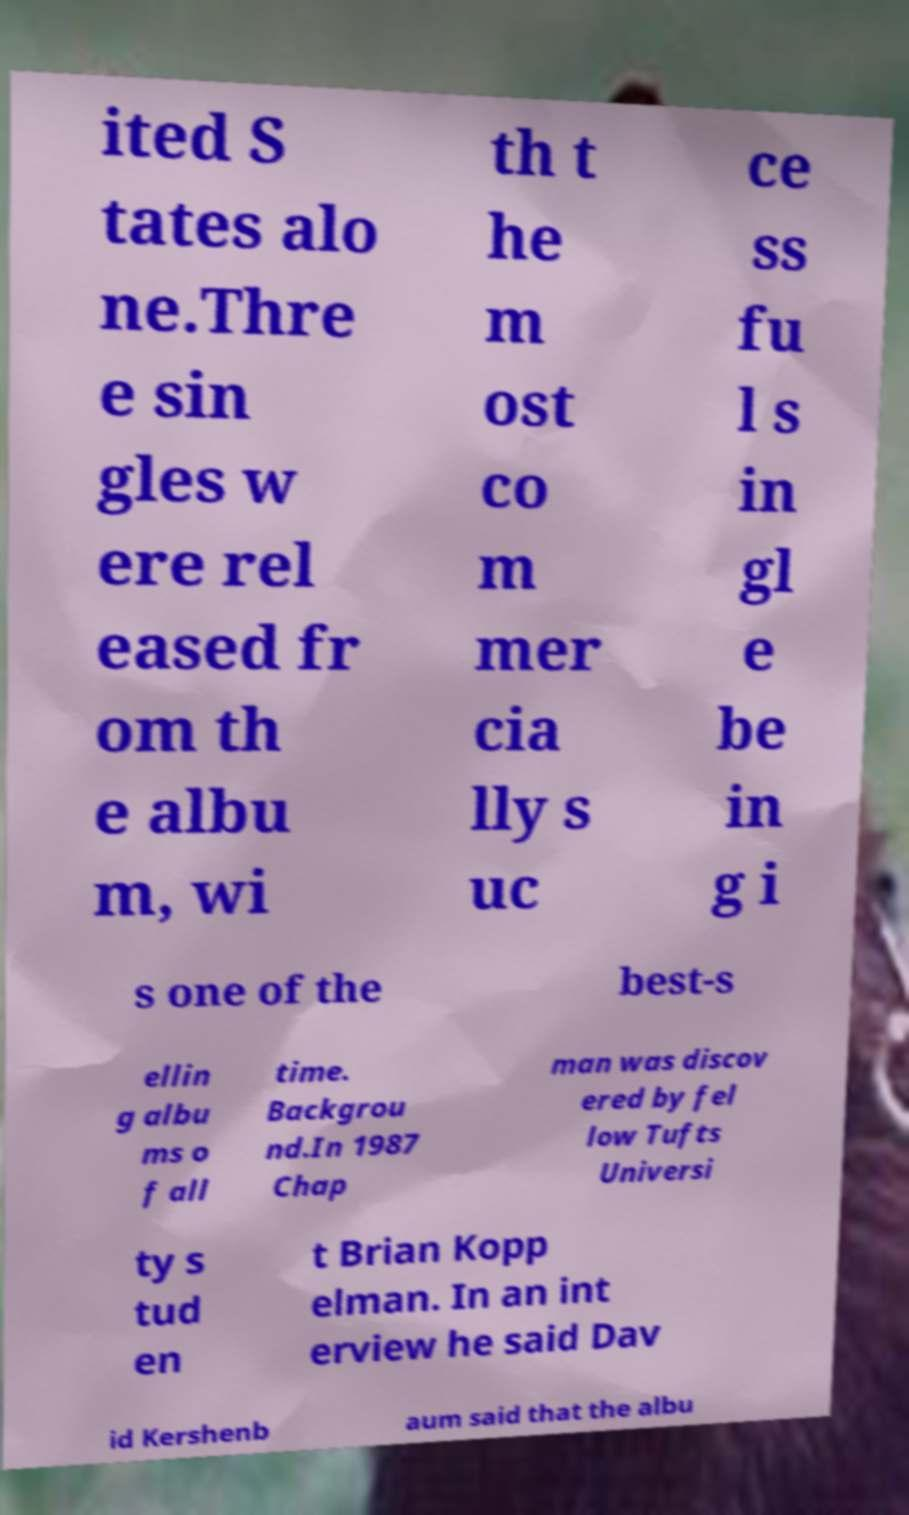Please identify and transcribe the text found in this image. ited S tates alo ne.Thre e sin gles w ere rel eased fr om th e albu m, wi th t he m ost co m mer cia lly s uc ce ss fu l s in gl e be in g i s one of the best-s ellin g albu ms o f all time. Backgrou nd.In 1987 Chap man was discov ered by fel low Tufts Universi ty s tud en t Brian Kopp elman. In an int erview he said Dav id Kershenb aum said that the albu 